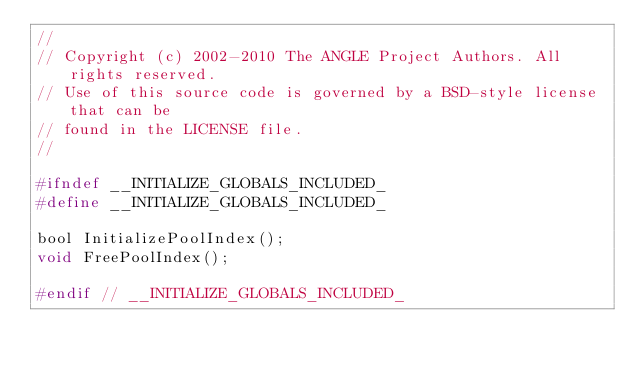<code> <loc_0><loc_0><loc_500><loc_500><_C_>//
// Copyright (c) 2002-2010 The ANGLE Project Authors. All rights reserved.
// Use of this source code is governed by a BSD-style license that can be
// found in the LICENSE file.
//

#ifndef __INITIALIZE_GLOBALS_INCLUDED_
#define __INITIALIZE_GLOBALS_INCLUDED_

bool InitializePoolIndex();
void FreePoolIndex();

#endif // __INITIALIZE_GLOBALS_INCLUDED_
</code> 